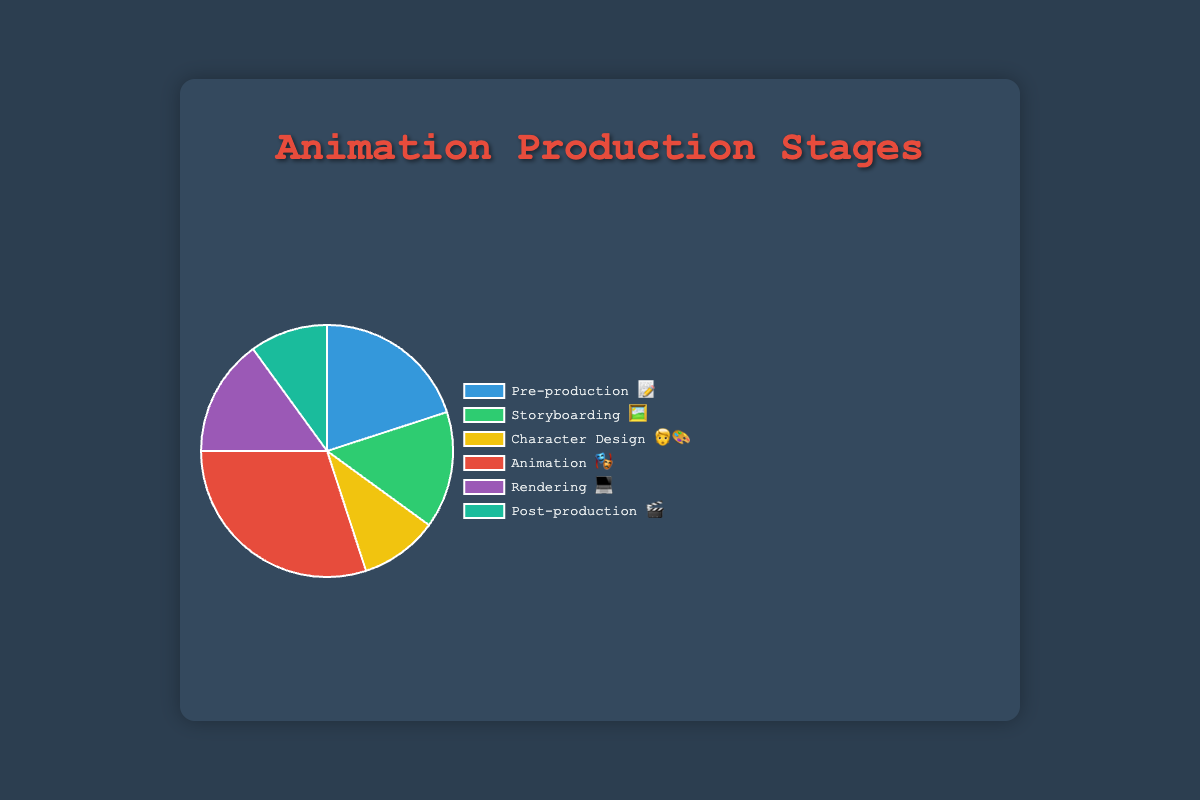What stage has the highest percentage of time spent? The animation stage has the highest percentage labeled with the 🎭 emoji and 30%.
Answer: Animation (30%) How much time is spent on Storyboarding and Rendering combined? Storyboarding and Rendering are labeled with 15% each. Adding them together gives 15% + 15% = 30%.
Answer: 30% Which stage has a lower percentage, Character Design or Post-production? Character Design and Post-production are both labeled with 10%. Since they are equal, neither is lower than the other.
Answer: They are equal (10%) What is the total percentage spent on Animation and Pre-production? Animation is labeled with 30% and Pre-production with 20%. Adding them together, 30% + 20% = 50%.
Answer: 50% How much more time is spent on Animation compared to Post-production? Animation is labeled with 30% and Post-production with 10%. The difference is 30% - 10% = 20%.
Answer: 20% What is the second most time-consuming stage? The second highest percentage is labeled with 20% for Pre-production (📝).
Answer: Pre-production (20%) Which stages have the same percentage of time allocation? Storyboarding (🖼️) and Rendering (💻) both are labeled with 15%. Character Design (🧑‍🎨) and Post-production (🎬) both are labeled with 10%.
Answer: Storyboarding and Rendering; Character Design and Post-production What is the average percentage spent across all stages? Adding all the percentages (20% + 15% + 10% + 30% + 15% + 10% = 100%) and dividing by 6 stages gives 100 / 6 ≈ 16.67%.
Answer: 16.67% 